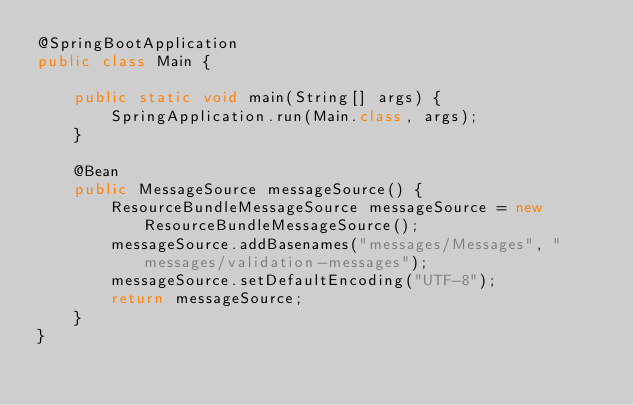<code> <loc_0><loc_0><loc_500><loc_500><_Java_>@SpringBootApplication
public class Main {

    public static void main(String[] args) {
        SpringApplication.run(Main.class, args);
    }
    
    @Bean
    public MessageSource messageSource() {
        ResourceBundleMessageSource messageSource = new ResourceBundleMessageSource();
        messageSource.addBasenames("messages/Messages", "messages/validation-messages");
        messageSource.setDefaultEncoding("UTF-8");
        return messageSource;
    }
}
</code> 